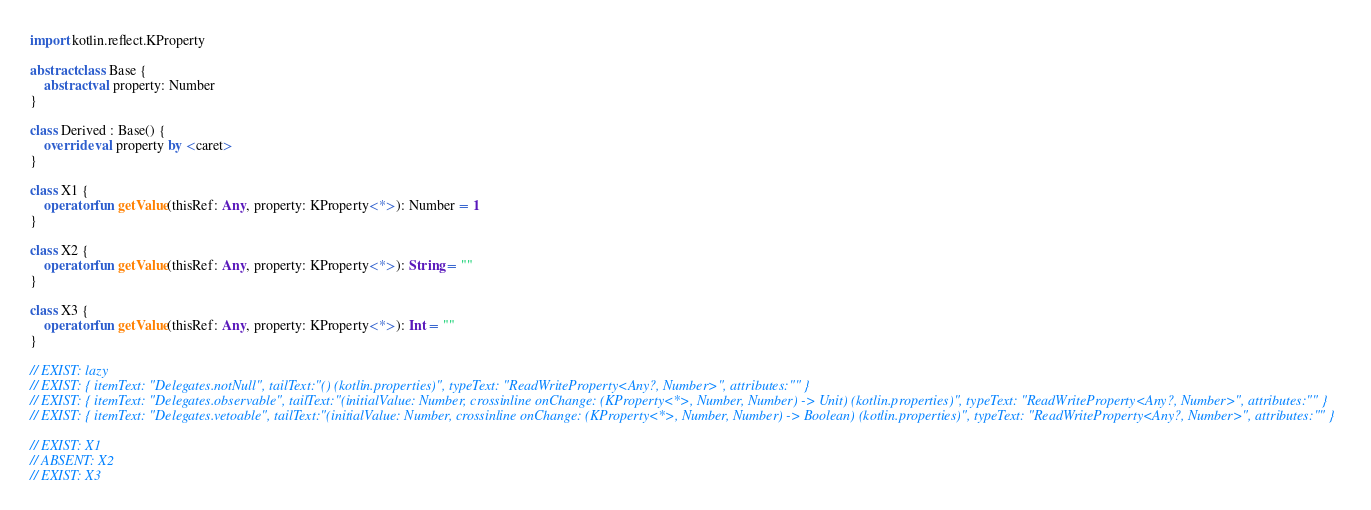<code> <loc_0><loc_0><loc_500><loc_500><_Kotlin_>import kotlin.reflect.KProperty

abstract class Base {
    abstract val property: Number
}

class Derived : Base() {
    override val property by <caret>
}

class X1 {
    operator fun getValue(thisRef: Any, property: KProperty<*>): Number = 1
}

class X2 {
    operator fun getValue(thisRef: Any, property: KProperty<*>): String = ""
}

class X3 {
    operator fun getValue(thisRef: Any, property: KProperty<*>): Int = ""
}

// EXIST: lazy
// EXIST: { itemText: "Delegates.notNull", tailText:"() (kotlin.properties)", typeText: "ReadWriteProperty<Any?, Number>", attributes:"" }
// EXIST: { itemText: "Delegates.observable", tailText:"(initialValue: Number, crossinline onChange: (KProperty<*>, Number, Number) -> Unit) (kotlin.properties)", typeText: "ReadWriteProperty<Any?, Number>", attributes:"" }
// EXIST: { itemText: "Delegates.vetoable", tailText:"(initialValue: Number, crossinline onChange: (KProperty<*>, Number, Number) -> Boolean) (kotlin.properties)", typeText: "ReadWriteProperty<Any?, Number>", attributes:"" }

// EXIST: X1
// ABSENT: X2
// EXIST: X3
</code> 